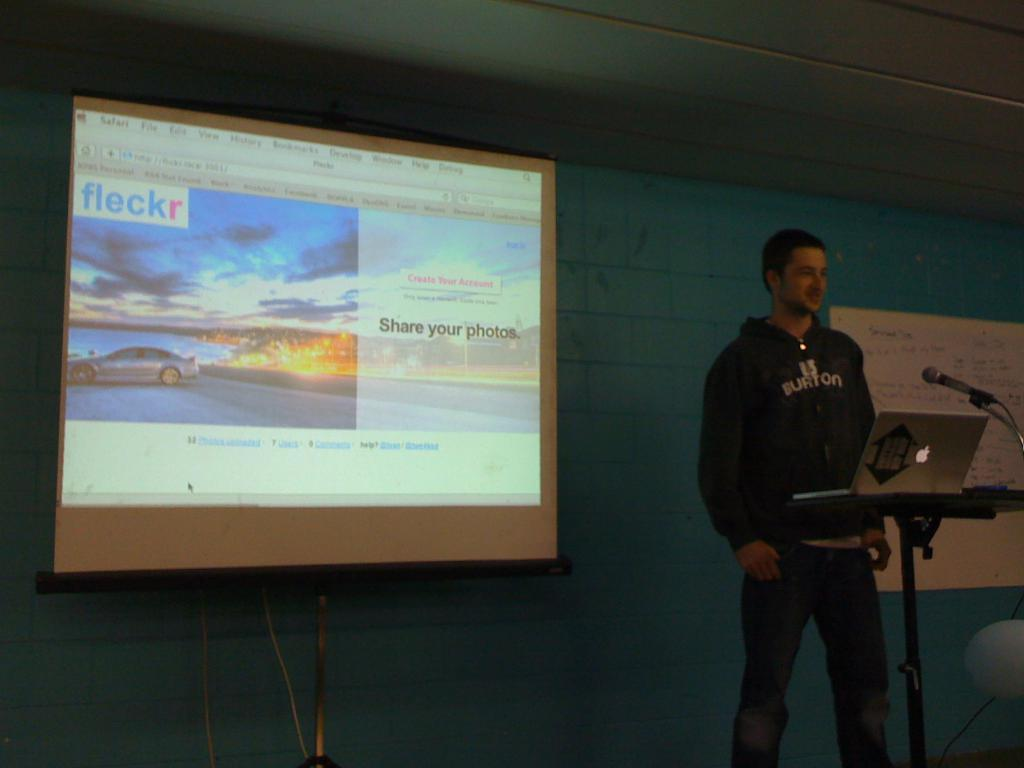<image>
Offer a succinct explanation of the picture presented. a man in a dark hoodie giving a presentation with a screen reading FLECKR 